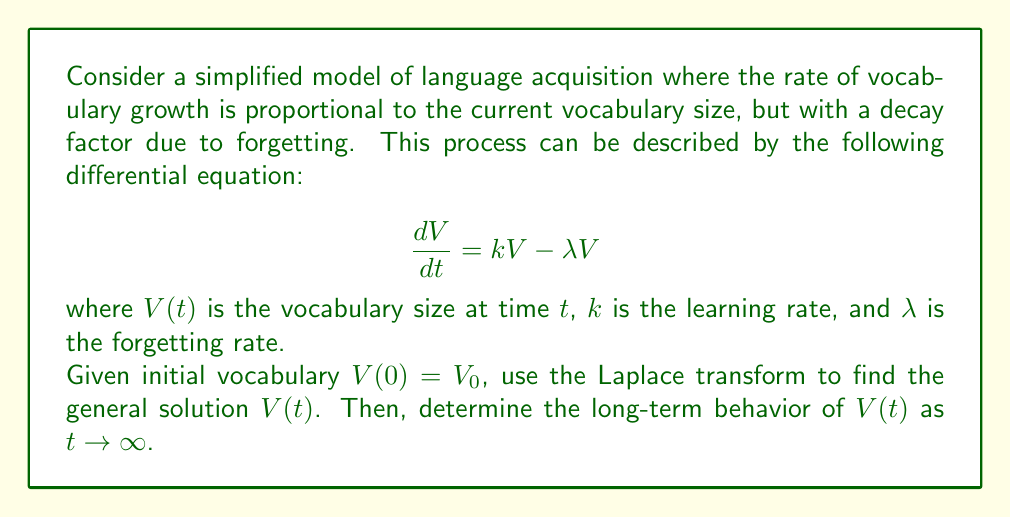Show me your answer to this math problem. Let's solve this step-by-step using the Laplace transform:

1) Take the Laplace transform of both sides of the equation:
   $$\mathcal{L}\left\{\frac{dV}{dt}\right\} = \mathcal{L}\{kV - \lambda V\}$$

2) Using the linearity property and the fact that $\mathcal{L}\left\{\frac{dV}{dt}\right\} = s\mathcal{L}\{V\} - V(0)$:
   $$s\mathcal{L}\{V\} - V_0 = (k-\lambda)\mathcal{L}\{V\}$$

3) Let $\mathcal{L}\{V\} = \bar{V}(s)$. Rearranging the equation:
   $$s\bar{V}(s) - V_0 = (k-\lambda)\bar{V}(s)$$
   $$s\bar{V}(s) - (k-\lambda)\bar{V}(s) = V_0$$
   $$[s - (k-\lambda)]\bar{V}(s) = V_0$$

4) Solve for $\bar{V}(s)$:
   $$\bar{V}(s) = \frac{V_0}{s - (k-\lambda)}$$

5) This is in the form of $\frac{A}{s-a}$, which has the inverse Laplace transform $Ae^{at}$. Therefore:
   $$V(t) = V_0e^{(k-\lambda)t}$$

6) To determine the long-term behavior as $t \to \infty$:
   - If $k > \lambda$, $V(t) \to \infty$ (exponential growth)
   - If $k < \lambda$, $V(t) \to 0$ (exponential decay)
   - If $k = \lambda$, $V(t) = V_0$ (constant)
Answer: $V(t) = V_0e^{(k-\lambda)t}$ 